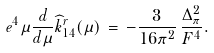<formula> <loc_0><loc_0><loc_500><loc_500>e ^ { 4 } \mu \frac { d } { d \mu } { \widehat { k } } ^ { r } _ { 1 4 } ( \mu ) \, = \, - \frac { 3 } { 1 6 \pi ^ { 2 } } \, \frac { \Delta _ { \pi } ^ { 2 } } { F ^ { 4 } } .</formula> 